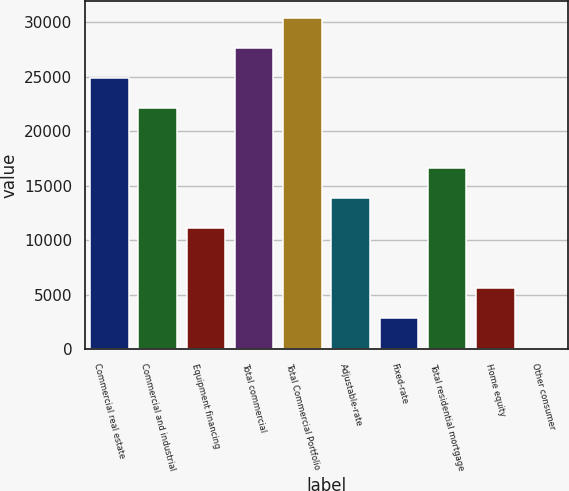Convert chart to OTSL. <chart><loc_0><loc_0><loc_500><loc_500><bar_chart><fcel>Commercial real estate<fcel>Commercial and industrial<fcel>Equipment financing<fcel>Total commercial<fcel>Total Commercial Portfolio<fcel>Adjustable-rate<fcel>Fixed-rate<fcel>Total residential mortgage<fcel>Home equity<fcel>Other consumer<nl><fcel>24857.7<fcel>22101.1<fcel>11074.8<fcel>27614.3<fcel>30370.9<fcel>13831.4<fcel>2805.08<fcel>16588<fcel>5561.66<fcel>48.5<nl></chart> 